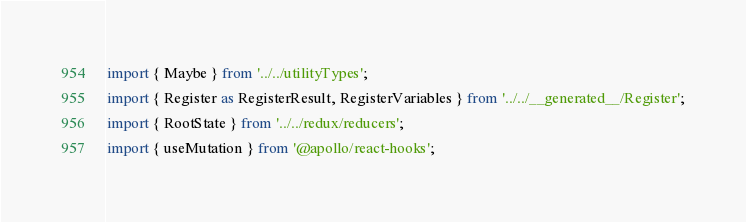<code> <loc_0><loc_0><loc_500><loc_500><_TypeScript_>import { Maybe } from '../../utilityTypes';
import { Register as RegisterResult, RegisterVariables } from '../../__generated__/Register';
import { RootState } from '../../redux/reducers';
import { useMutation } from '@apollo/react-hooks';</code> 